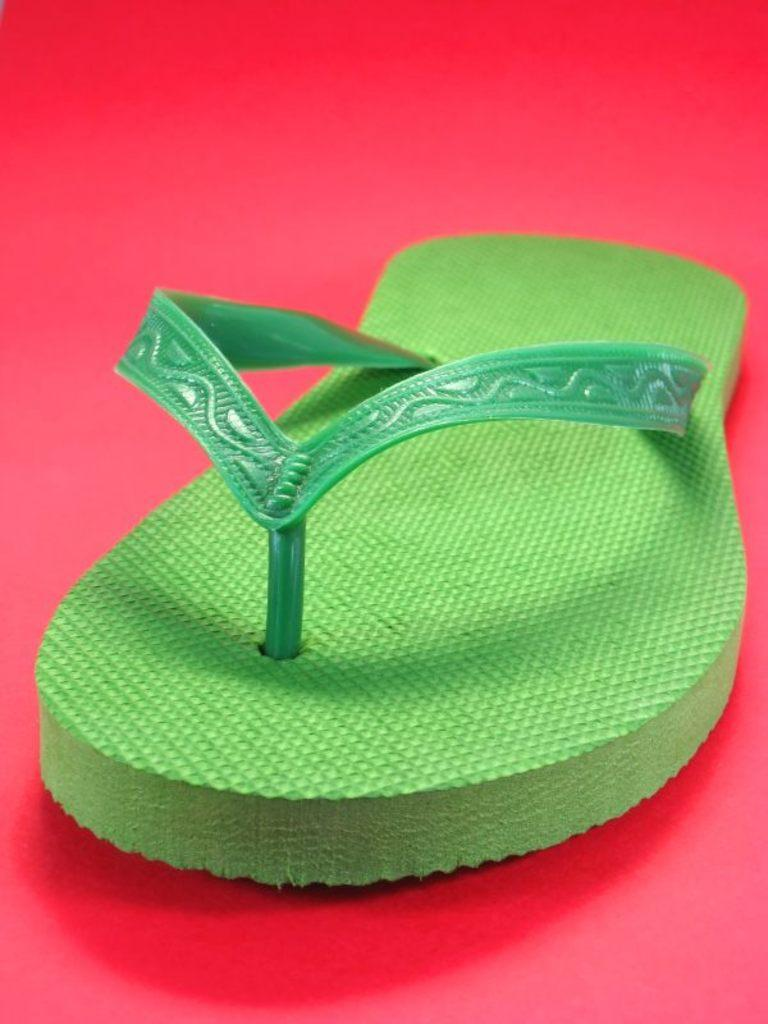What is the main feature in the center of the image? There is a red carpet in the center of the image. What is placed on the red carpet? There is a pair of footwear on the carpet. What color are the footwear? The footwear is green in color. How does the coil of the footwear affect its appearance in the image? There is no coil present on the footwear in the image, so this detail cannot be discussed. 